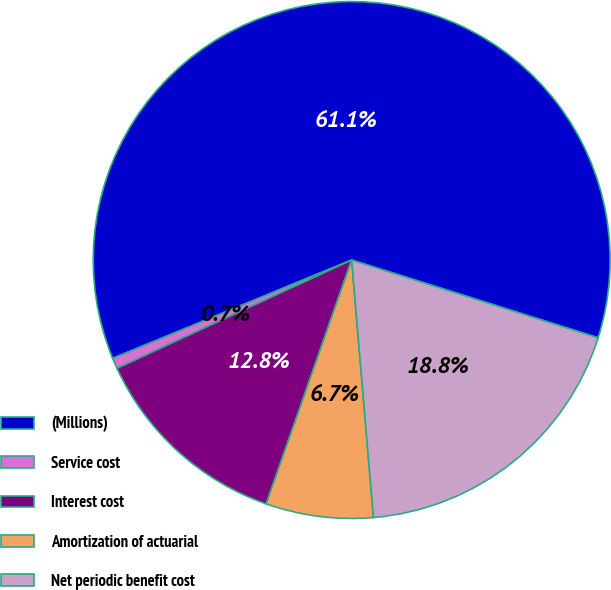Convert chart to OTSL. <chart><loc_0><loc_0><loc_500><loc_500><pie_chart><fcel>(Millions)<fcel>Service cost<fcel>Interest cost<fcel>Amortization of actuarial<fcel>Net periodic benefit cost<nl><fcel>61.08%<fcel>0.67%<fcel>12.75%<fcel>6.71%<fcel>18.79%<nl></chart> 